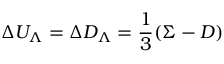Convert formula to latex. <formula><loc_0><loc_0><loc_500><loc_500>\Delta U _ { \Lambda } = \Delta D _ { \Lambda } = \frac { 1 } { 3 } ( \Sigma - D )</formula> 